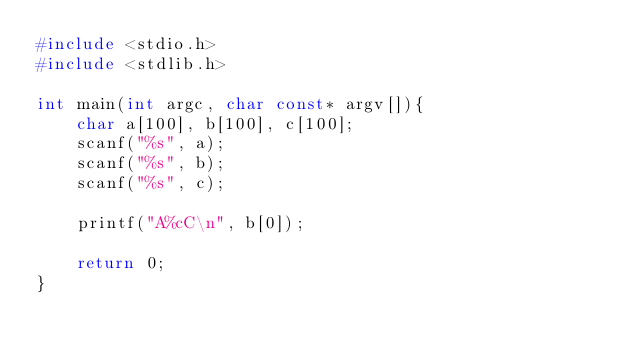<code> <loc_0><loc_0><loc_500><loc_500><_C_>#include <stdio.h>
#include <stdlib.h>

int main(int argc, char const* argv[]){
    char a[100], b[100], c[100];
    scanf("%s", a);
    scanf("%s", b);
    scanf("%s", c);

    printf("A%cC\n", b[0]);

    return 0;
}</code> 